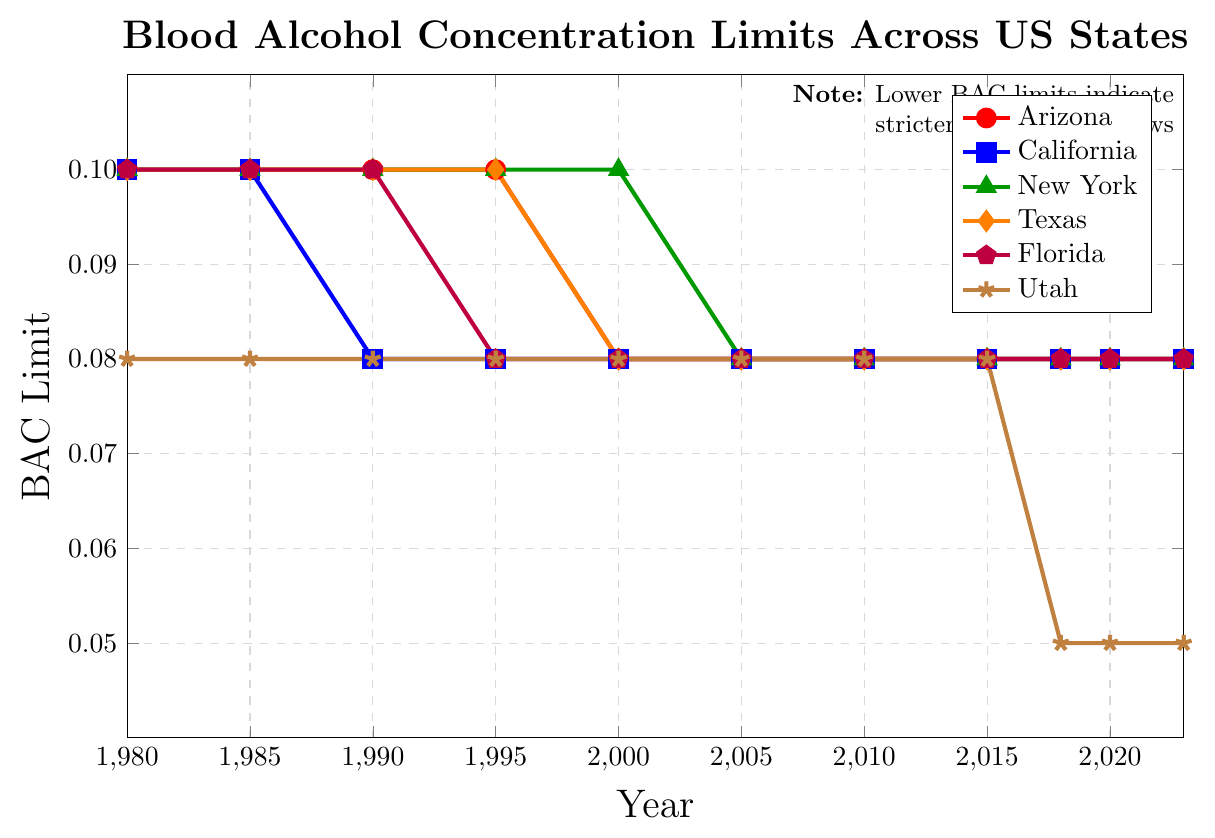What's the starting BAC limit for Arizona? The starting BAC limit for Arizona in 1980 is shown as 0.10 based on the red line in the graph.
Answer: 0.10 Which state had the lowest BAC limit in 2023? In 2023, the BAC limit for Utah, represented by the brown line, is the lowest at 0.05.
Answer: Utah In what year did New York and Texas change their BAC limit to 0.08? Following the green and orange lines for New York and Texas, their BAC limits changed to 0.08 in the year 2005.
Answer: 2005 How did the BAC limit for Arizona change between 1980 and 2000? The Arizona BAC limit remained at 0.10 from 1980 to 1995 and then dropped to 0.08 in 2000, shown by the step change in the red line.
Answer: Dropped from 0.10 to 0.08 Compare the BAC limits of Florida and Utah in 2018. In 2018, Florida had a BAC limit of 0.08, while Utah had a BAC limit of 0.05, respectively shown by the purple and brown lines.
Answer: Florida: 0.08, Utah: 0.05 Calculate the average BAC limit for California from 1980 to 2023. The BAC limits for California are: 0.10 (1980-1985), 0.08 (1990-2023). Average = (0.10 + 0.10 + 0.08 + 0.08 + 0.08 + 0.08 + 0.08 + 0.08 + 0.08 + 0.08 + 0.08) / 11 = 0.084
Answer: 0.084 When did Florida first change its BAC limit from 0.10? Florida first changed its BAC limit from 0.10 to 0.08 in 1995, indicated by the drop in the purple line.
Answer: 1995 Between 2000 and 2023, which state had the most significant drop in BAC limit? Utah had the most significant drop in BAC limit from 0.08 in 2000 to 0.05 in 2018, as shown by the brown line.
Answer: Utah Was the BAC limit for all states equal at any point in the timeline? All states appear to have an equal BAC limit of 0.08 from 2005 onwards, except for Utah which drops to 0.05 in 2018.
Answer: No What is the difference in BAC limits for Arizona and New York in 1990? In 1990, the BAC limit for Arizona is 0.10 and for New York is 0.10. Therefore, the difference is 0.10 - 0.10 = 0.
Answer: 0 